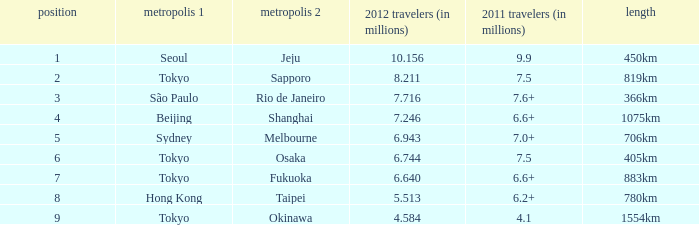How many passengers (in millions) flew through along the route that is 1075km long in 2012? 7.246. 